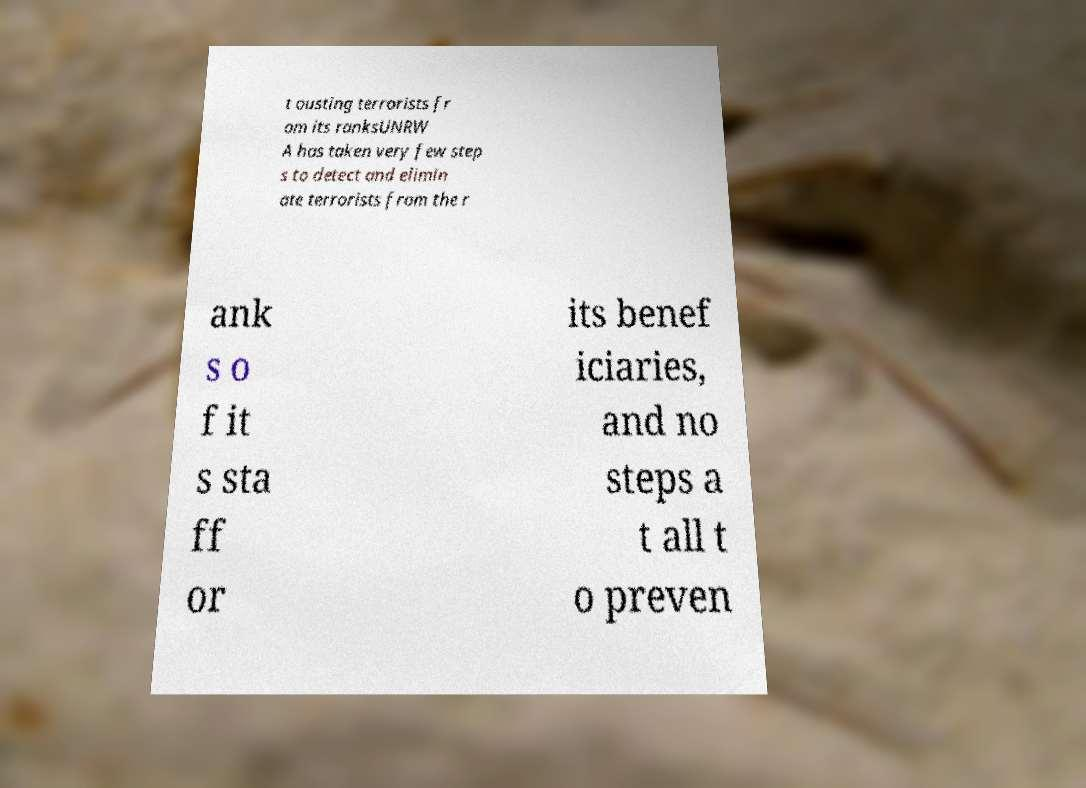I need the written content from this picture converted into text. Can you do that? t ousting terrorists fr om its ranksUNRW A has taken very few step s to detect and elimin ate terrorists from the r ank s o f it s sta ff or its benef iciaries, and no steps a t all t o preven 